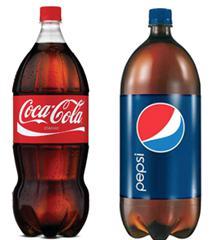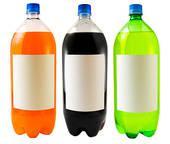The first image is the image on the left, the second image is the image on the right. Evaluate the accuracy of this statement regarding the images: "Exactly three bottles of fizzy drink can be seen in each image.". Is it true? Answer yes or no. No. The first image is the image on the left, the second image is the image on the right. Evaluate the accuracy of this statement regarding the images: "The left image shows exactly three bottles of different colored liquids with no labels, and the right image shows three soda bottles with printed labels on the front.". Is it true? Answer yes or no. No. 